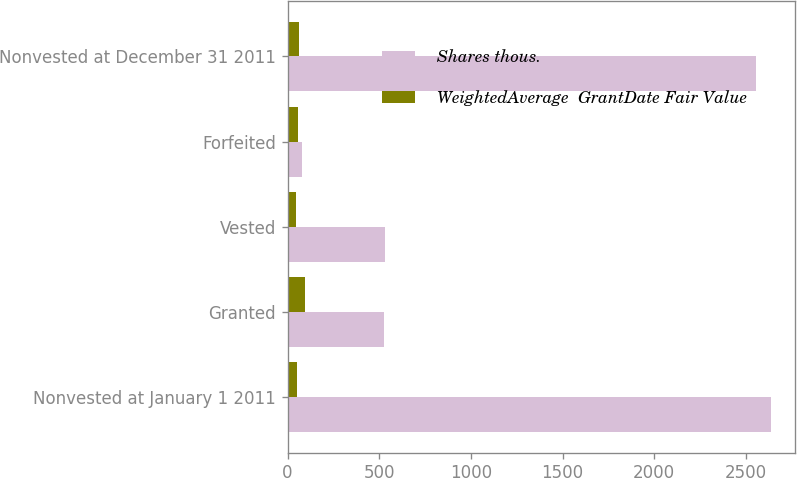Convert chart. <chart><loc_0><loc_0><loc_500><loc_500><stacked_bar_chart><ecel><fcel>Nonvested at January 1 2011<fcel>Granted<fcel>Vested<fcel>Forfeited<fcel>Nonvested at December 31 2011<nl><fcel>Shares thous.<fcel>2638<fcel>528<fcel>532<fcel>78<fcel>2556<nl><fcel>WeightedAverage  GrantDate Fair Value<fcel>54.01<fcel>93.68<fcel>48.69<fcel>57.72<fcel>63.2<nl></chart> 